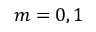Convert formula to latex. <formula><loc_0><loc_0><loc_500><loc_500>m = 0 , 1</formula> 